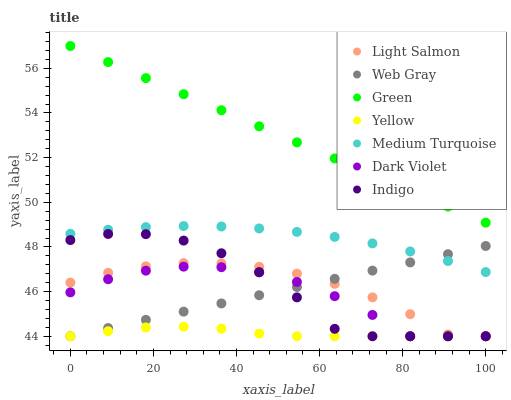Does Yellow have the minimum area under the curve?
Answer yes or no. Yes. Does Green have the maximum area under the curve?
Answer yes or no. Yes. Does Web Gray have the minimum area under the curve?
Answer yes or no. No. Does Web Gray have the maximum area under the curve?
Answer yes or no. No. Is Green the smoothest?
Answer yes or no. Yes. Is Indigo the roughest?
Answer yes or no. Yes. Is Web Gray the smoothest?
Answer yes or no. No. Is Web Gray the roughest?
Answer yes or no. No. Does Light Salmon have the lowest value?
Answer yes or no. Yes. Does Green have the lowest value?
Answer yes or no. No. Does Green have the highest value?
Answer yes or no. Yes. Does Web Gray have the highest value?
Answer yes or no. No. Is Indigo less than Green?
Answer yes or no. Yes. Is Medium Turquoise greater than Light Salmon?
Answer yes or no. Yes. Does Medium Turquoise intersect Web Gray?
Answer yes or no. Yes. Is Medium Turquoise less than Web Gray?
Answer yes or no. No. Is Medium Turquoise greater than Web Gray?
Answer yes or no. No. Does Indigo intersect Green?
Answer yes or no. No. 